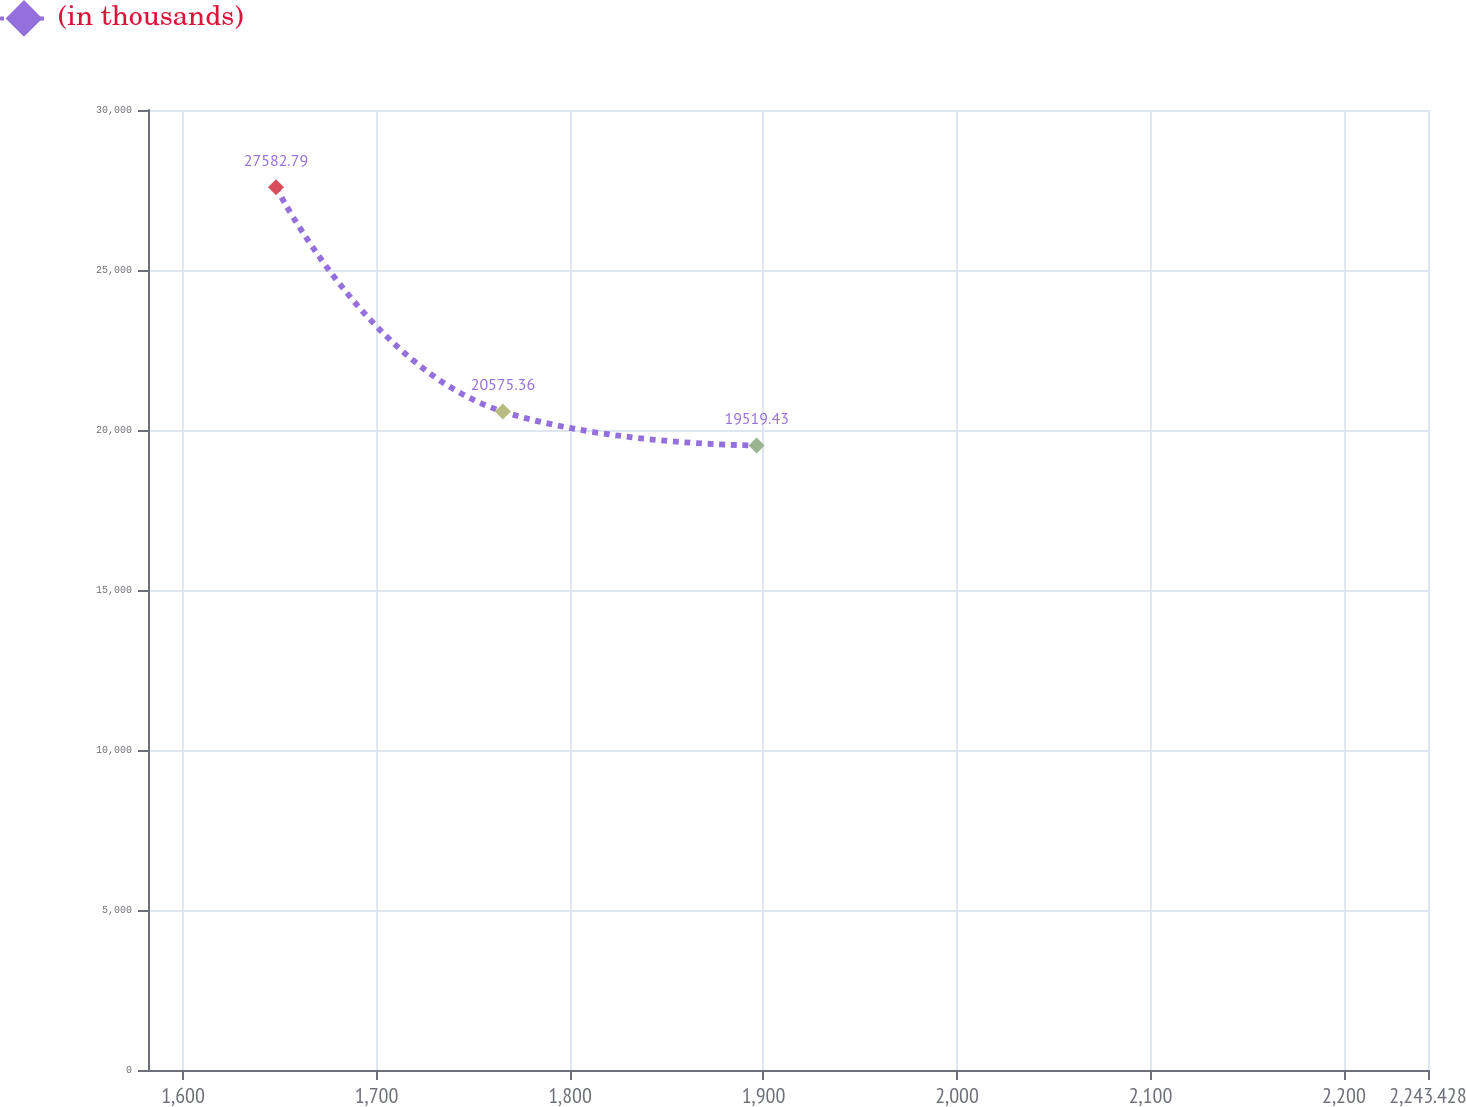<chart> <loc_0><loc_0><loc_500><loc_500><line_chart><ecel><fcel>(in thousands)<nl><fcel>1648.06<fcel>27582.8<nl><fcel>1765.32<fcel>20575.4<nl><fcel>1896.46<fcel>19519.4<nl><fcel>2245.45<fcel>17023.5<nl><fcel>2309.58<fcel>21631.3<nl></chart> 